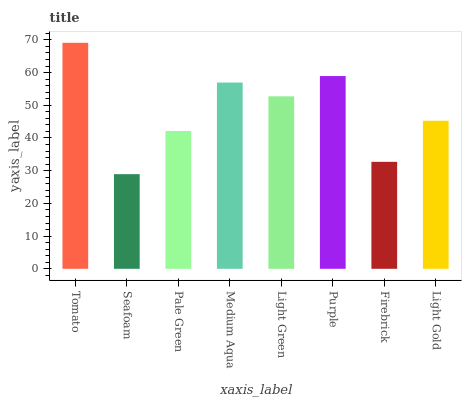Is Seafoam the minimum?
Answer yes or no. Yes. Is Tomato the maximum?
Answer yes or no. Yes. Is Pale Green the minimum?
Answer yes or no. No. Is Pale Green the maximum?
Answer yes or no. No. Is Pale Green greater than Seafoam?
Answer yes or no. Yes. Is Seafoam less than Pale Green?
Answer yes or no. Yes. Is Seafoam greater than Pale Green?
Answer yes or no. No. Is Pale Green less than Seafoam?
Answer yes or no. No. Is Light Green the high median?
Answer yes or no. Yes. Is Light Gold the low median?
Answer yes or no. Yes. Is Tomato the high median?
Answer yes or no. No. Is Firebrick the low median?
Answer yes or no. No. 